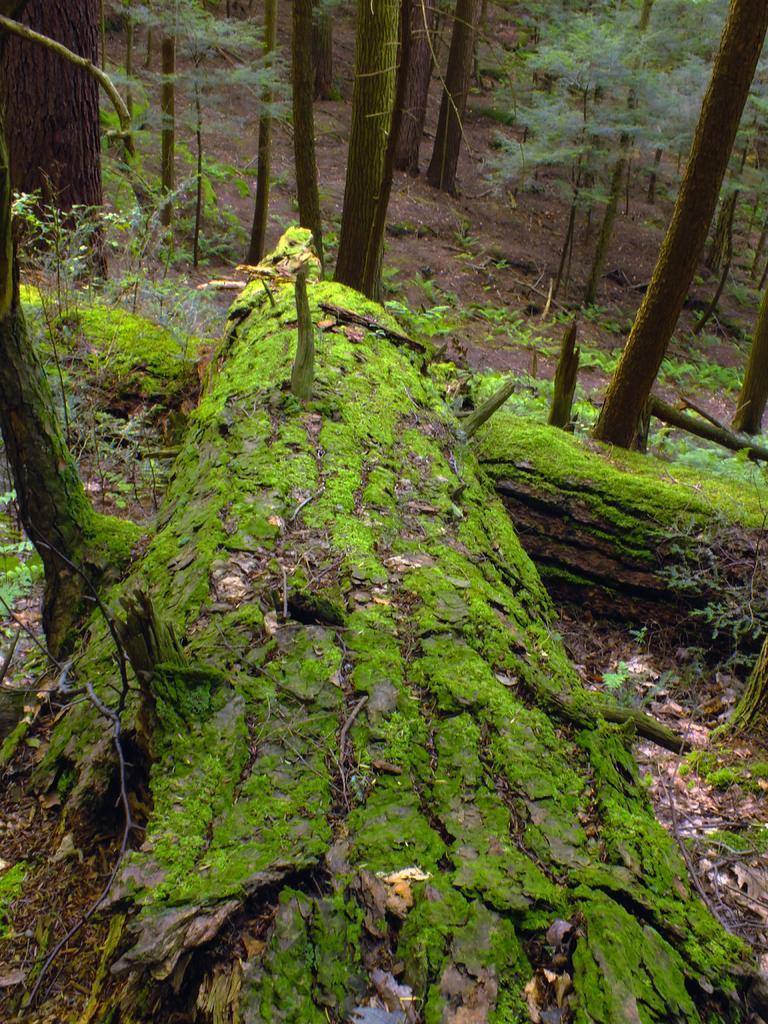Describe this image in one or two sentences. In this picture, we can see the ground with some trees and plants. 